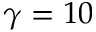Convert formula to latex. <formula><loc_0><loc_0><loc_500><loc_500>\gamma = 1 0</formula> 